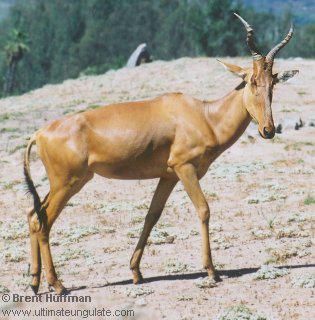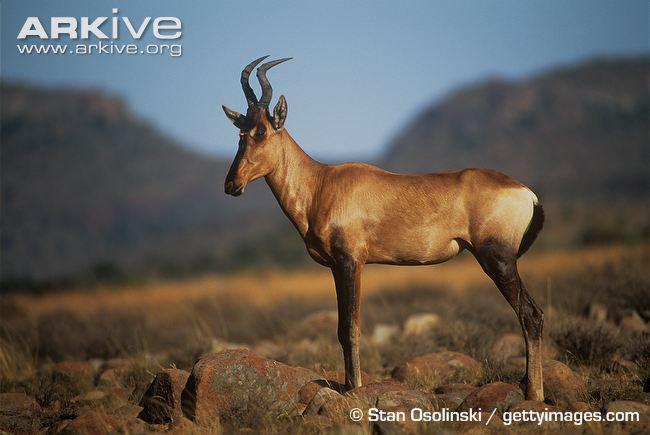The first image is the image on the left, the second image is the image on the right. For the images displayed, is the sentence "There are exactly two goats." factually correct? Answer yes or no. Yes. The first image is the image on the left, the second image is the image on the right. Assess this claim about the two images: "Each image contains a single horned animal, which is standing on all four legs with its body in profile.". Correct or not? Answer yes or no. Yes. 